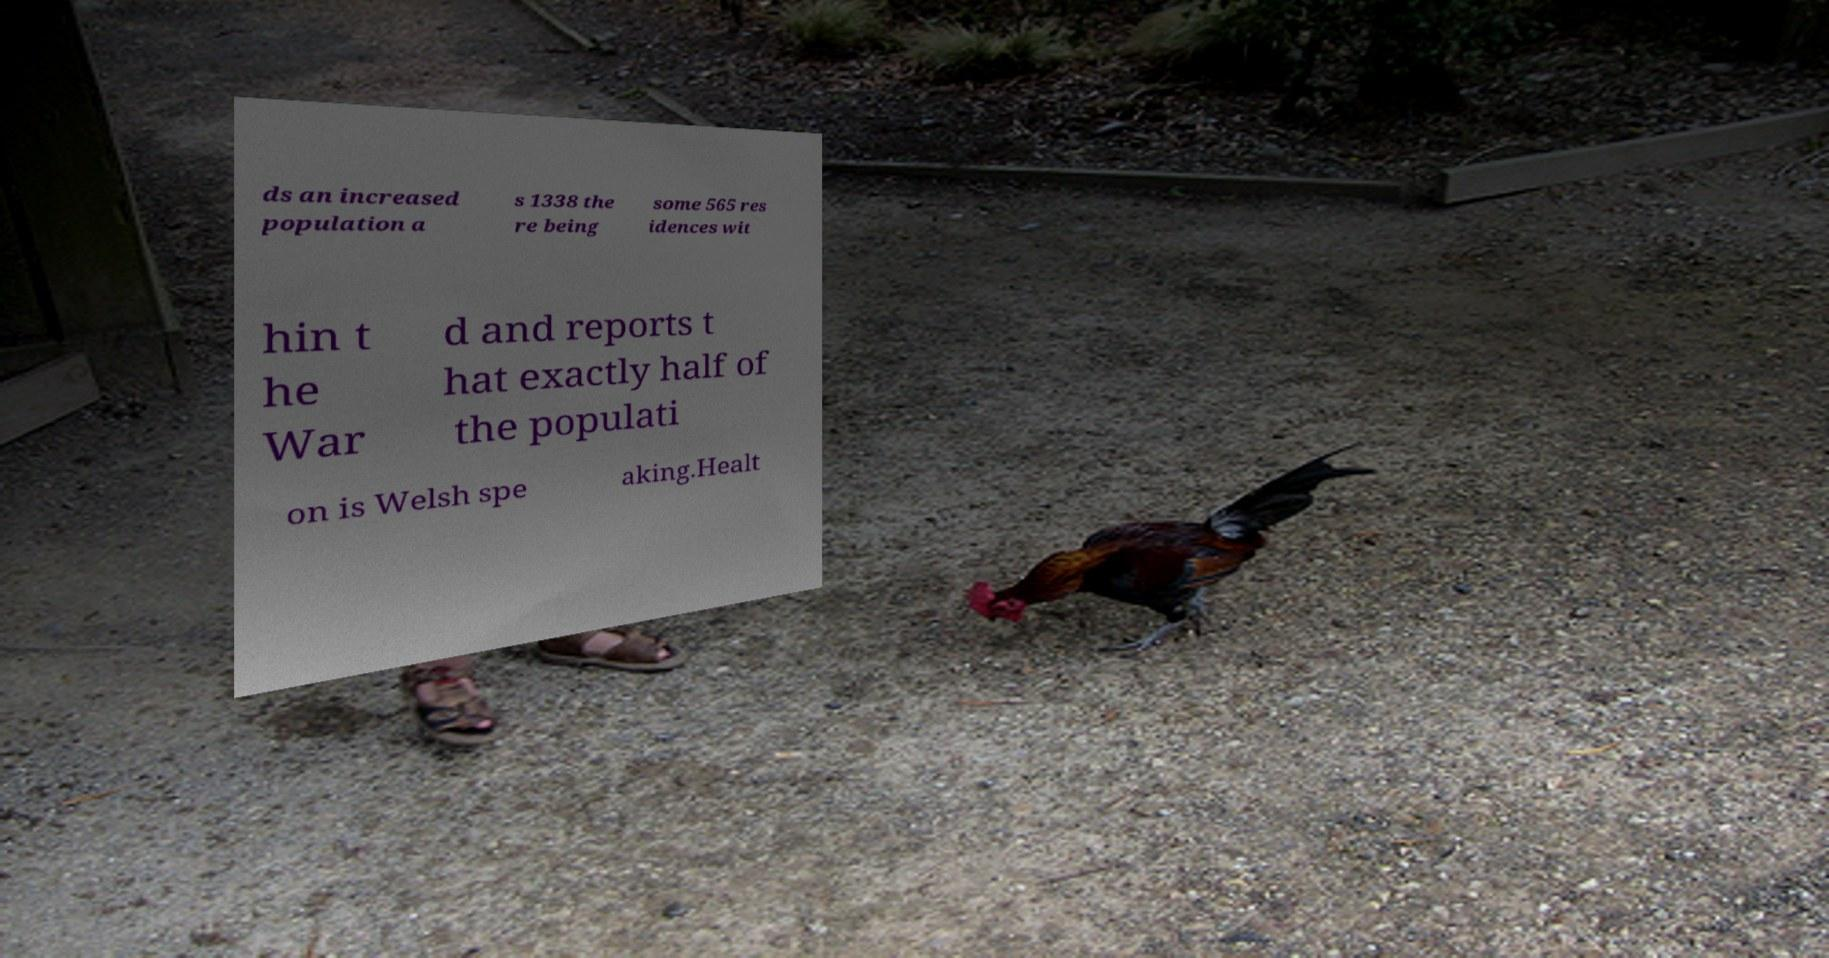Please read and relay the text visible in this image. What does it say? ds an increased population a s 1338 the re being some 565 res idences wit hin t he War d and reports t hat exactly half of the populati on is Welsh spe aking.Healt 